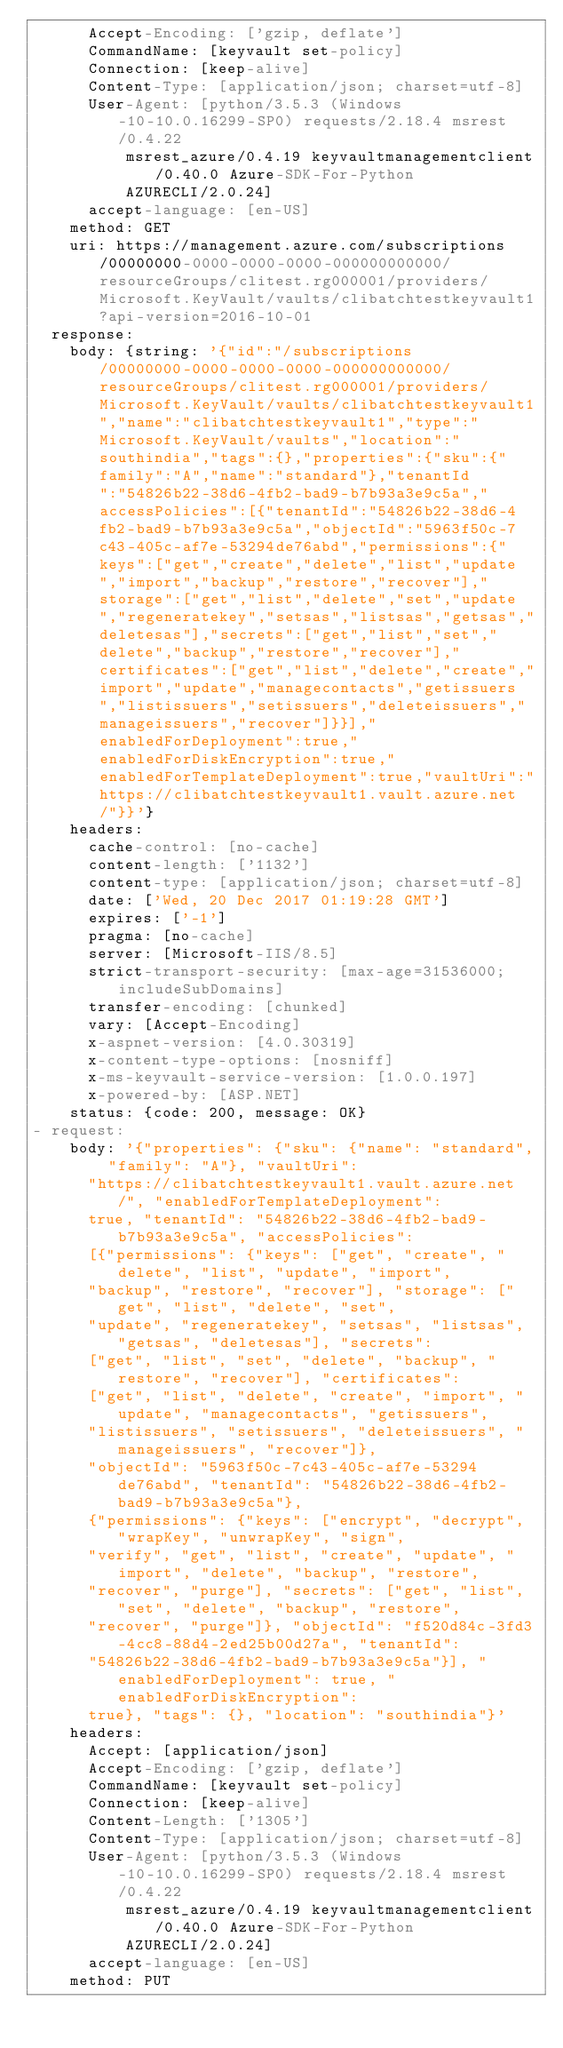<code> <loc_0><loc_0><loc_500><loc_500><_YAML_>      Accept-Encoding: ['gzip, deflate']
      CommandName: [keyvault set-policy]
      Connection: [keep-alive]
      Content-Type: [application/json; charset=utf-8]
      User-Agent: [python/3.5.3 (Windows-10-10.0.16299-SP0) requests/2.18.4 msrest/0.4.22
          msrest_azure/0.4.19 keyvaultmanagementclient/0.40.0 Azure-SDK-For-Python
          AZURECLI/2.0.24]
      accept-language: [en-US]
    method: GET
    uri: https://management.azure.com/subscriptions/00000000-0000-0000-0000-000000000000/resourceGroups/clitest.rg000001/providers/Microsoft.KeyVault/vaults/clibatchtestkeyvault1?api-version=2016-10-01
  response:
    body: {string: '{"id":"/subscriptions/00000000-0000-0000-0000-000000000000/resourceGroups/clitest.rg000001/providers/Microsoft.KeyVault/vaults/clibatchtestkeyvault1","name":"clibatchtestkeyvault1","type":"Microsoft.KeyVault/vaults","location":"southindia","tags":{},"properties":{"sku":{"family":"A","name":"standard"},"tenantId":"54826b22-38d6-4fb2-bad9-b7b93a3e9c5a","accessPolicies":[{"tenantId":"54826b22-38d6-4fb2-bad9-b7b93a3e9c5a","objectId":"5963f50c-7c43-405c-af7e-53294de76abd","permissions":{"keys":["get","create","delete","list","update","import","backup","restore","recover"],"storage":["get","list","delete","set","update","regeneratekey","setsas","listsas","getsas","deletesas"],"secrets":["get","list","set","delete","backup","restore","recover"],"certificates":["get","list","delete","create","import","update","managecontacts","getissuers","listissuers","setissuers","deleteissuers","manageissuers","recover"]}}],"enabledForDeployment":true,"enabledForDiskEncryption":true,"enabledForTemplateDeployment":true,"vaultUri":"https://clibatchtestkeyvault1.vault.azure.net/"}}'}
    headers:
      cache-control: [no-cache]
      content-length: ['1132']
      content-type: [application/json; charset=utf-8]
      date: ['Wed, 20 Dec 2017 01:19:28 GMT']
      expires: ['-1']
      pragma: [no-cache]
      server: [Microsoft-IIS/8.5]
      strict-transport-security: [max-age=31536000; includeSubDomains]
      transfer-encoding: [chunked]
      vary: [Accept-Encoding]
      x-aspnet-version: [4.0.30319]
      x-content-type-options: [nosniff]
      x-ms-keyvault-service-version: [1.0.0.197]
      x-powered-by: [ASP.NET]
    status: {code: 200, message: OK}
- request:
    body: '{"properties": {"sku": {"name": "standard", "family": "A"}, "vaultUri":
      "https://clibatchtestkeyvault1.vault.azure.net/", "enabledForTemplateDeployment":
      true, "tenantId": "54826b22-38d6-4fb2-bad9-b7b93a3e9c5a", "accessPolicies":
      [{"permissions": {"keys": ["get", "create", "delete", "list", "update", "import",
      "backup", "restore", "recover"], "storage": ["get", "list", "delete", "set",
      "update", "regeneratekey", "setsas", "listsas", "getsas", "deletesas"], "secrets":
      ["get", "list", "set", "delete", "backup", "restore", "recover"], "certificates":
      ["get", "list", "delete", "create", "import", "update", "managecontacts", "getissuers",
      "listissuers", "setissuers", "deleteissuers", "manageissuers", "recover"]},
      "objectId": "5963f50c-7c43-405c-af7e-53294de76abd", "tenantId": "54826b22-38d6-4fb2-bad9-b7b93a3e9c5a"},
      {"permissions": {"keys": ["encrypt", "decrypt", "wrapKey", "unwrapKey", "sign",
      "verify", "get", "list", "create", "update", "import", "delete", "backup", "restore",
      "recover", "purge"], "secrets": ["get", "list", "set", "delete", "backup", "restore",
      "recover", "purge"]}, "objectId": "f520d84c-3fd3-4cc8-88d4-2ed25b00d27a", "tenantId":
      "54826b22-38d6-4fb2-bad9-b7b93a3e9c5a"}], "enabledForDeployment": true, "enabledForDiskEncryption":
      true}, "tags": {}, "location": "southindia"}'
    headers:
      Accept: [application/json]
      Accept-Encoding: ['gzip, deflate']
      CommandName: [keyvault set-policy]
      Connection: [keep-alive]
      Content-Length: ['1305']
      Content-Type: [application/json; charset=utf-8]
      User-Agent: [python/3.5.3 (Windows-10-10.0.16299-SP0) requests/2.18.4 msrest/0.4.22
          msrest_azure/0.4.19 keyvaultmanagementclient/0.40.0 Azure-SDK-For-Python
          AZURECLI/2.0.24]
      accept-language: [en-US]
    method: PUT</code> 